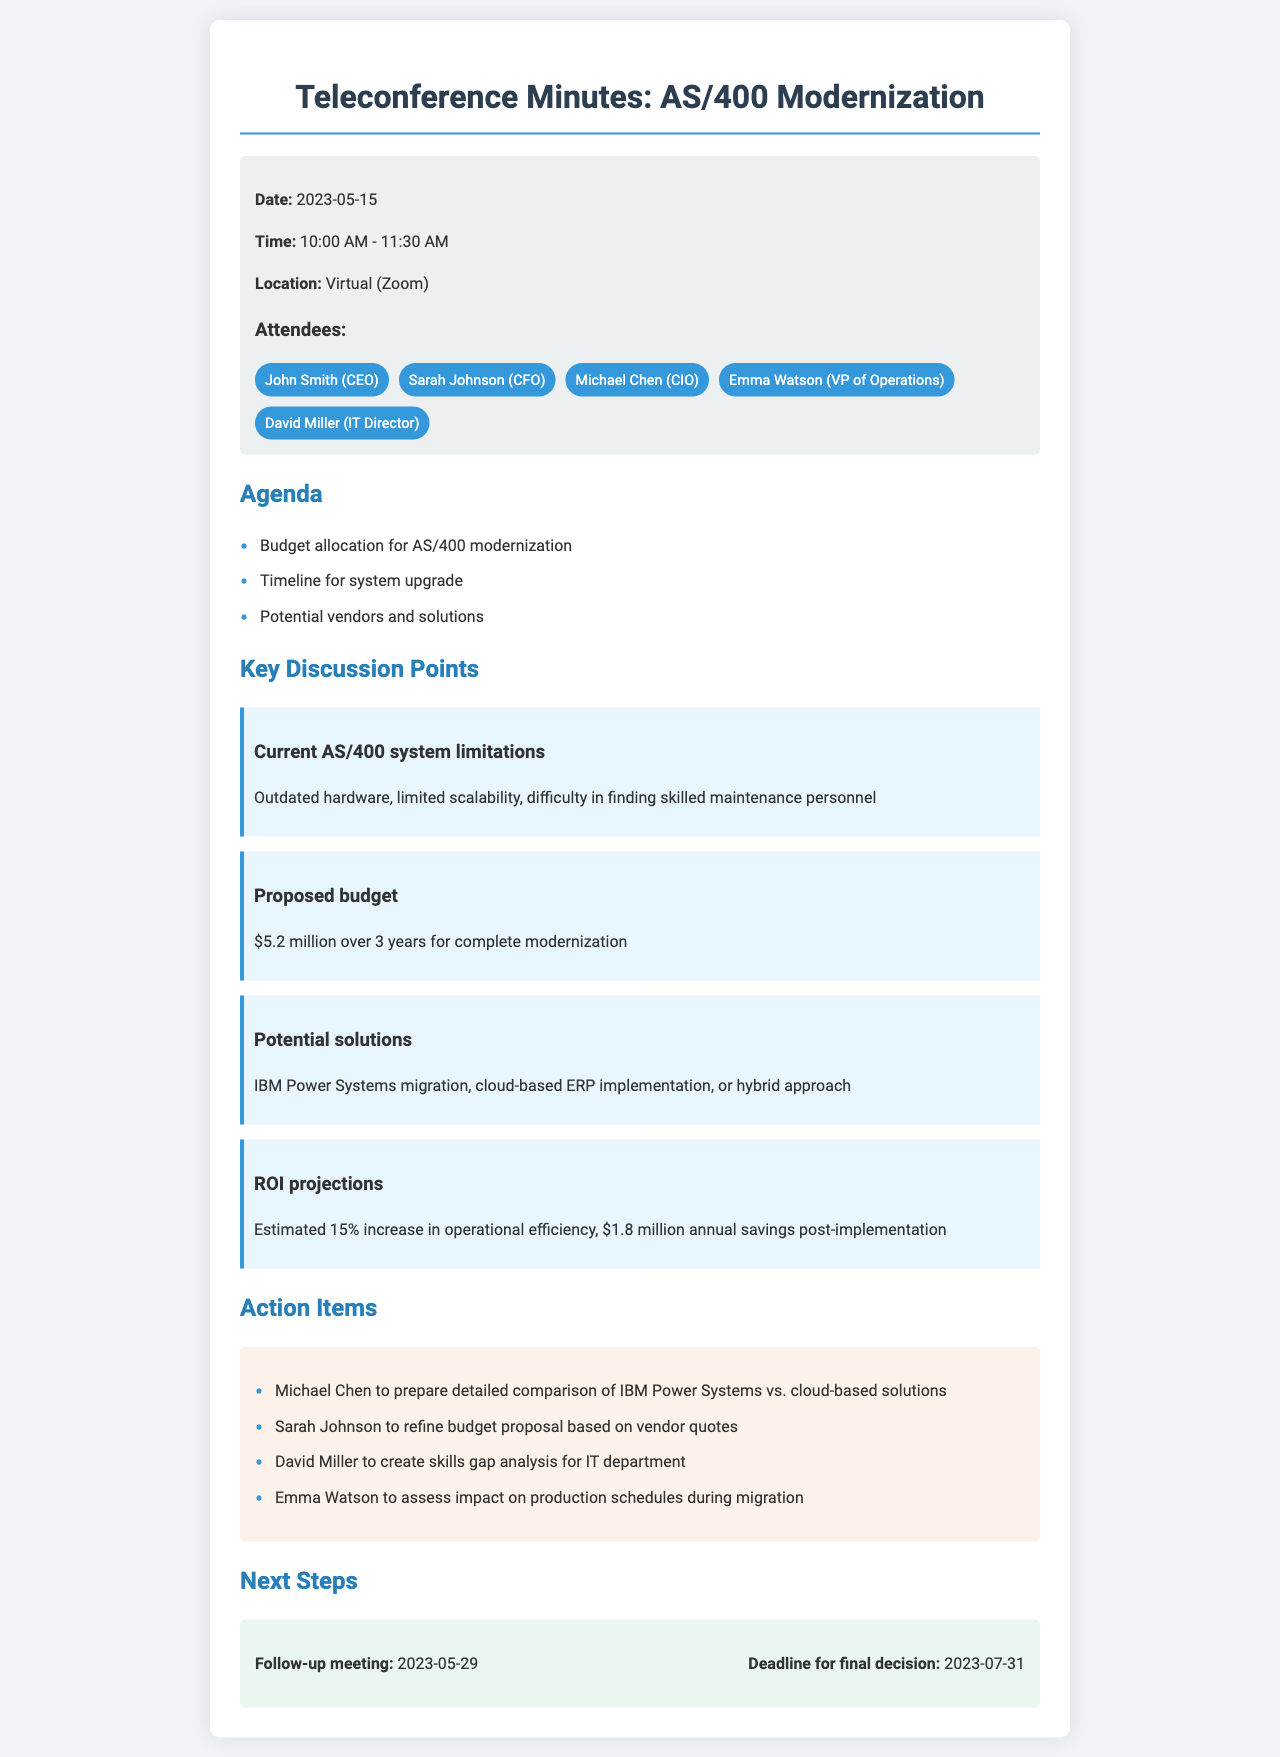What is the date of the meeting? The date is explicitly stated in the document under meeting details as May 15, 2023.
Answer: May 15, 2023 Who is the CFO attending the meeting? The document lists the attendees, and the individual representing the CFO role is Sarah Johnson.
Answer: Sarah Johnson What is the proposed budget for modernization? The proposed budget is detailed in the key discussion points section, indicated as $5.2 million over 3 years.
Answer: $5.2 million What is the follow-up meeting date? The follow-up meeting date is mentioned in the next steps section as May 29, 2023.
Answer: May 29, 2023 What is the estimated increase in operational efficiency after modernization? The ROI projections mention a 15% increase in operational efficiency as an outcome of the modernization.
Answer: 15% Which attendee is responsible for the skills gap analysis? The action items section assigns David Miller to create the skills gap analysis for the IT department.
Answer: David Miller What platform was used for the meeting? The location specifies that the meeting was held virtually on Zoom.
Answer: Zoom What is the deadline for the final decision? The document mentions the final decision deadline in next steps as July 31, 2023.
Answer: July 31, 2023 What solution is mentioned for potential implementation? The key discussion points list potential solutions, including IBM Power Systems migration, among others.
Answer: IBM Power Systems migration 